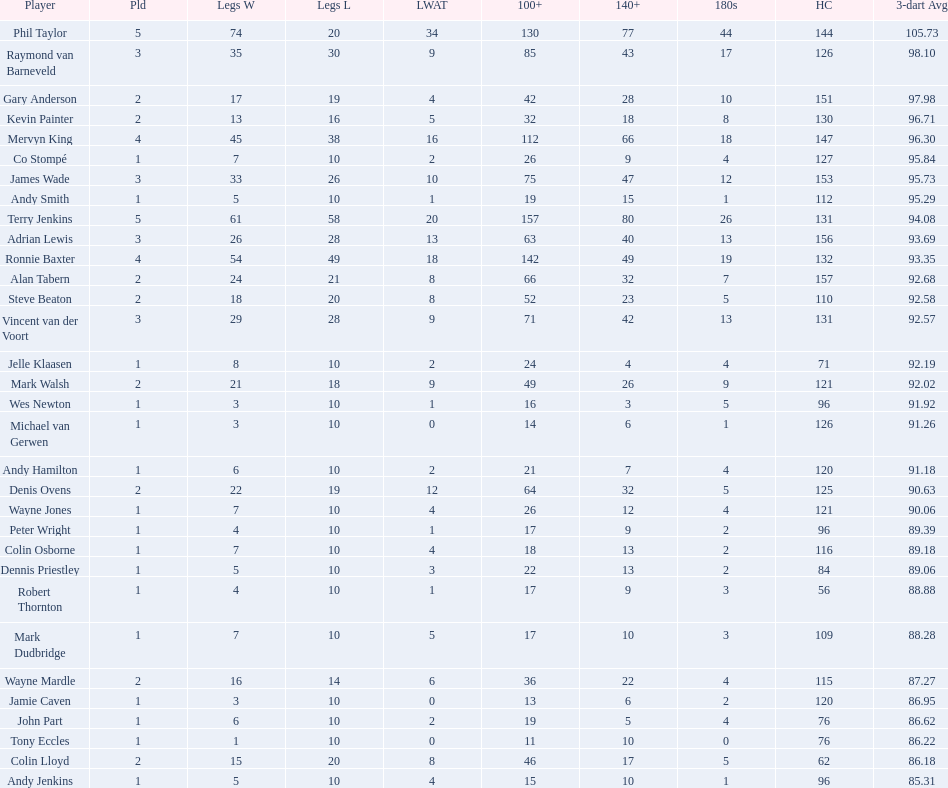Was andy smith or kevin painter's 3-dart average 96.71? Kevin Painter. 